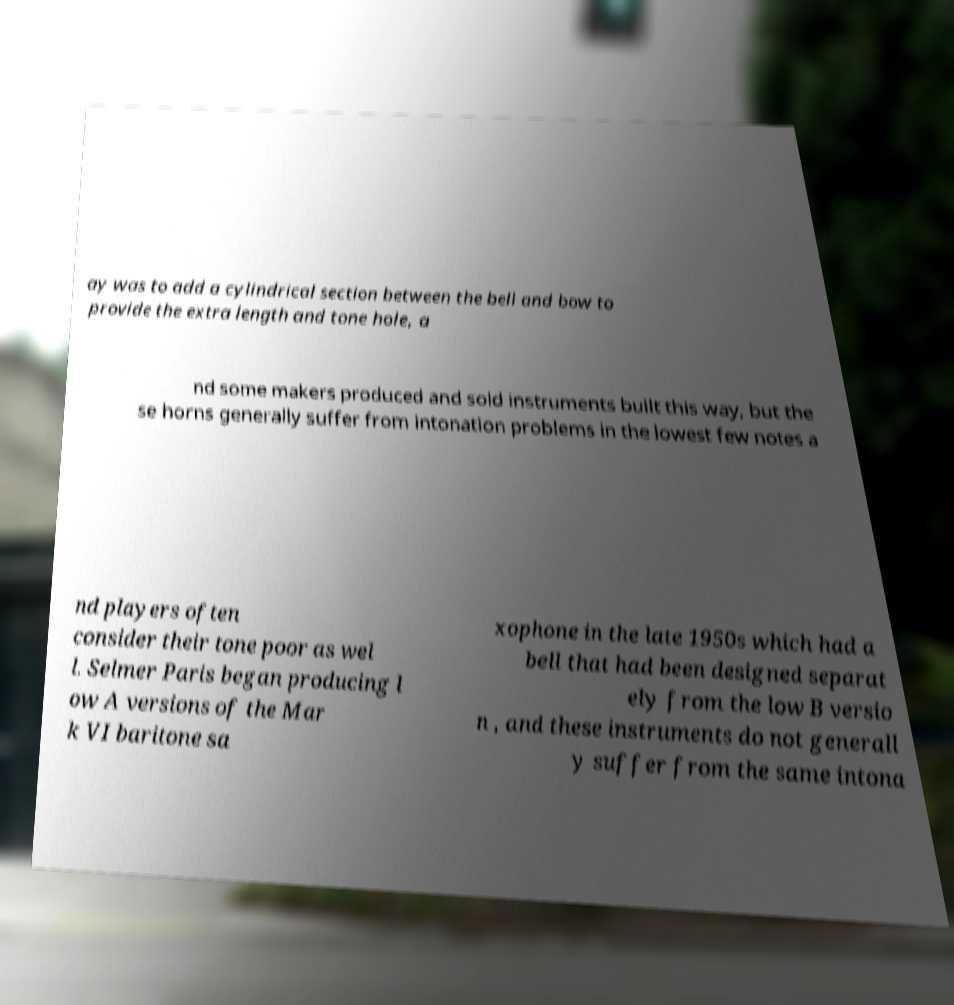Please identify and transcribe the text found in this image. ay was to add a cylindrical section between the bell and bow to provide the extra length and tone hole, a nd some makers produced and sold instruments built this way, but the se horns generally suffer from intonation problems in the lowest few notes a nd players often consider their tone poor as wel l. Selmer Paris began producing l ow A versions of the Mar k VI baritone sa xophone in the late 1950s which had a bell that had been designed separat ely from the low B versio n , and these instruments do not generall y suffer from the same intona 